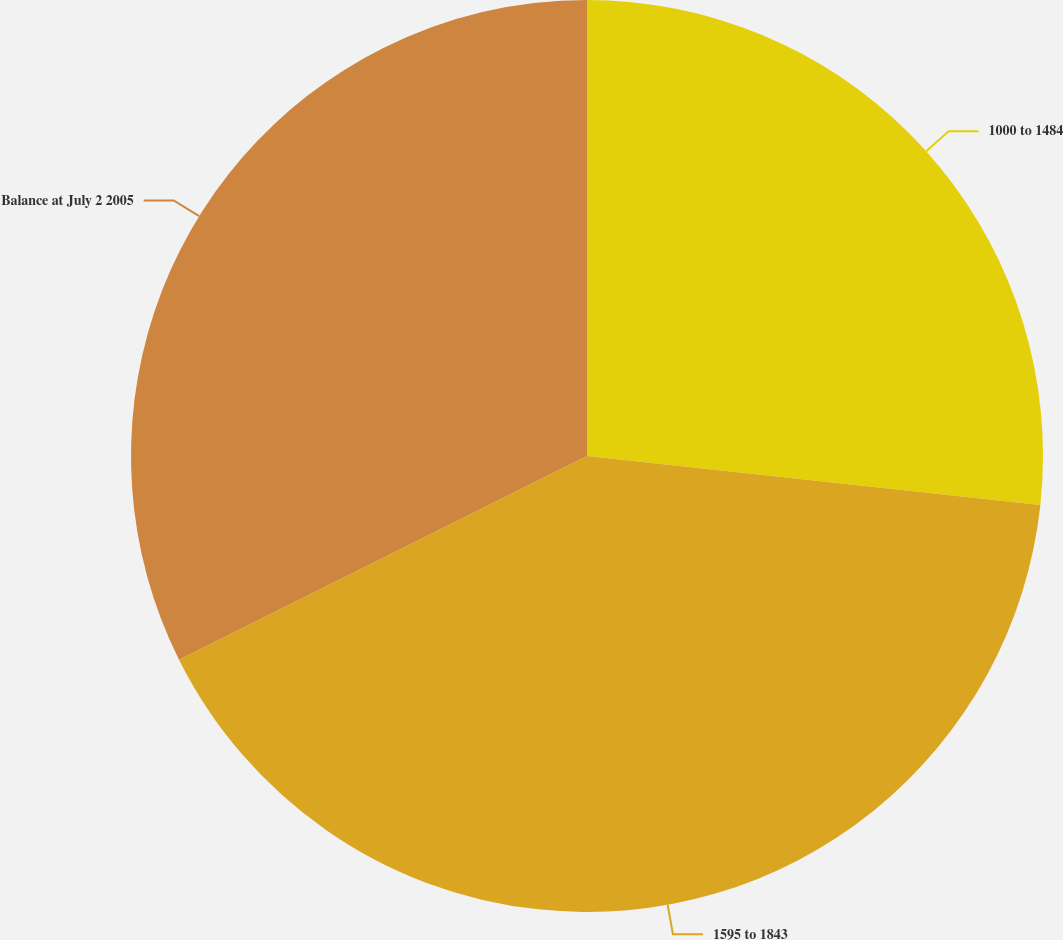Convert chart to OTSL. <chart><loc_0><loc_0><loc_500><loc_500><pie_chart><fcel>1000 to 1484<fcel>1595 to 1843<fcel>Balance at July 2 2005<nl><fcel>26.71%<fcel>40.92%<fcel>32.37%<nl></chart> 